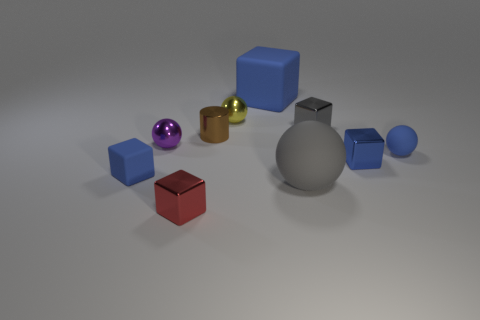Subtract all yellow spheres. How many blue blocks are left? 3 Subtract all yellow cubes. Subtract all purple cylinders. How many cubes are left? 5 Subtract all spheres. How many objects are left? 6 Add 4 small red metallic things. How many small red metallic things exist? 5 Subtract 0 yellow cubes. How many objects are left? 10 Subtract all large yellow spheres. Subtract all large blue blocks. How many objects are left? 9 Add 3 blue metallic blocks. How many blue metallic blocks are left? 4 